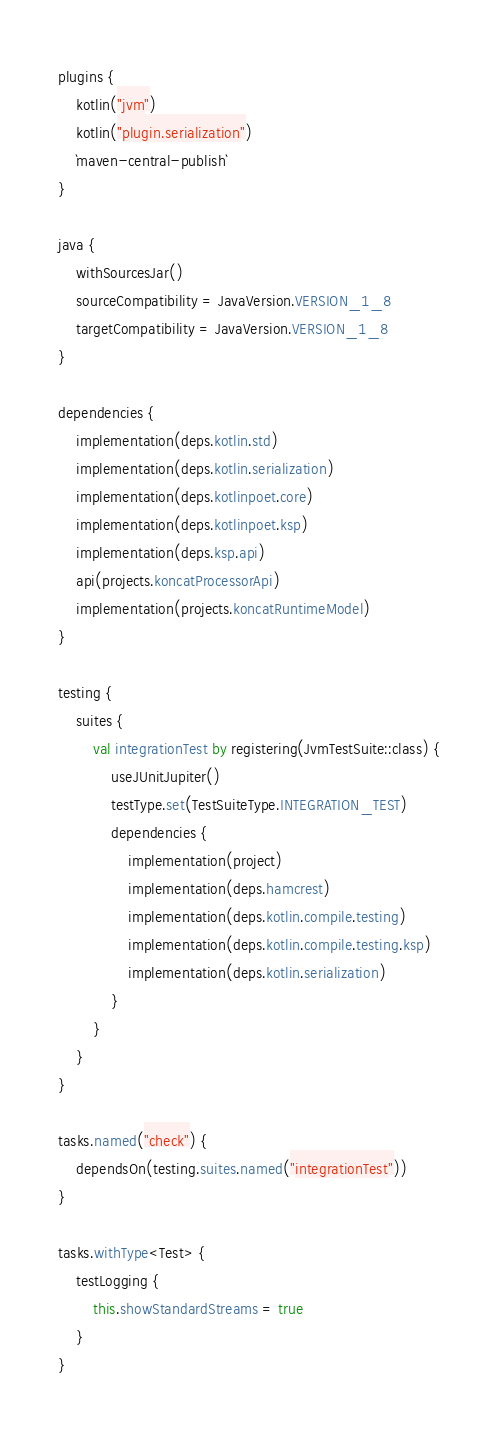Convert code to text. <code><loc_0><loc_0><loc_500><loc_500><_Kotlin_>plugins {
    kotlin("jvm")
    kotlin("plugin.serialization")
    `maven-central-publish`
}

java {
    withSourcesJar()
    sourceCompatibility = JavaVersion.VERSION_1_8
    targetCompatibility = JavaVersion.VERSION_1_8
}

dependencies {
    implementation(deps.kotlin.std)
    implementation(deps.kotlin.serialization)
    implementation(deps.kotlinpoet.core)
    implementation(deps.kotlinpoet.ksp)
    implementation(deps.ksp.api)
    api(projects.koncatProcessorApi)
    implementation(projects.koncatRuntimeModel)
}

testing {
    suites {
        val integrationTest by registering(JvmTestSuite::class) {
            useJUnitJupiter()
            testType.set(TestSuiteType.INTEGRATION_TEST)
            dependencies {
                implementation(project)
                implementation(deps.hamcrest)
                implementation(deps.kotlin.compile.testing)
                implementation(deps.kotlin.compile.testing.ksp)
                implementation(deps.kotlin.serialization)
            }
        }
    }
}

tasks.named("check") {
    dependsOn(testing.suites.named("integrationTest"))
}

tasks.withType<Test> {
    testLogging {
        this.showStandardStreams = true
    }
}</code> 